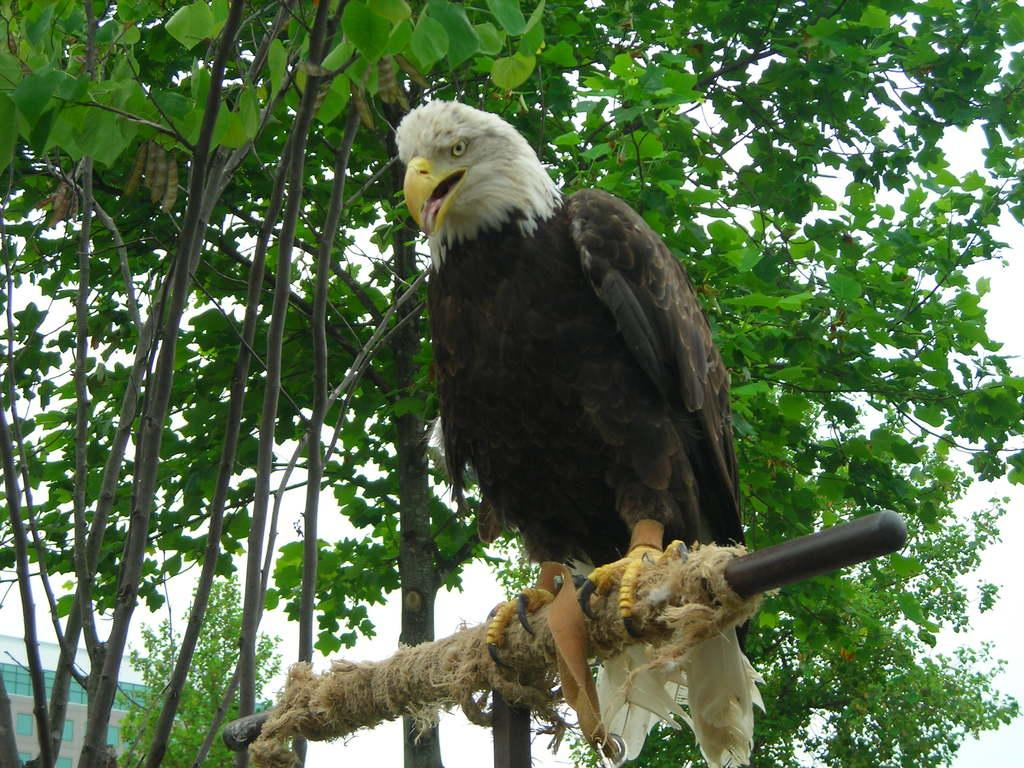What type of animal can be seen in the image? There is a bird in the image. What can be seen in the background of the image? There are trees in the background of the image. What type of structure is present in the image? There is a building with windows in the image. What type of reward is the bird holding in the image? There is no reward present in the image; it is a bird in a natural setting. 